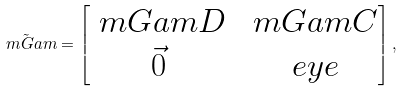Convert formula to latex. <formula><loc_0><loc_0><loc_500><loc_500>\tilde { \ m G a m } = \begin{bmatrix} \ m G a m D & \ m G a m C \\ \vec { 0 } & \ e y e \end{bmatrix} ,</formula> 